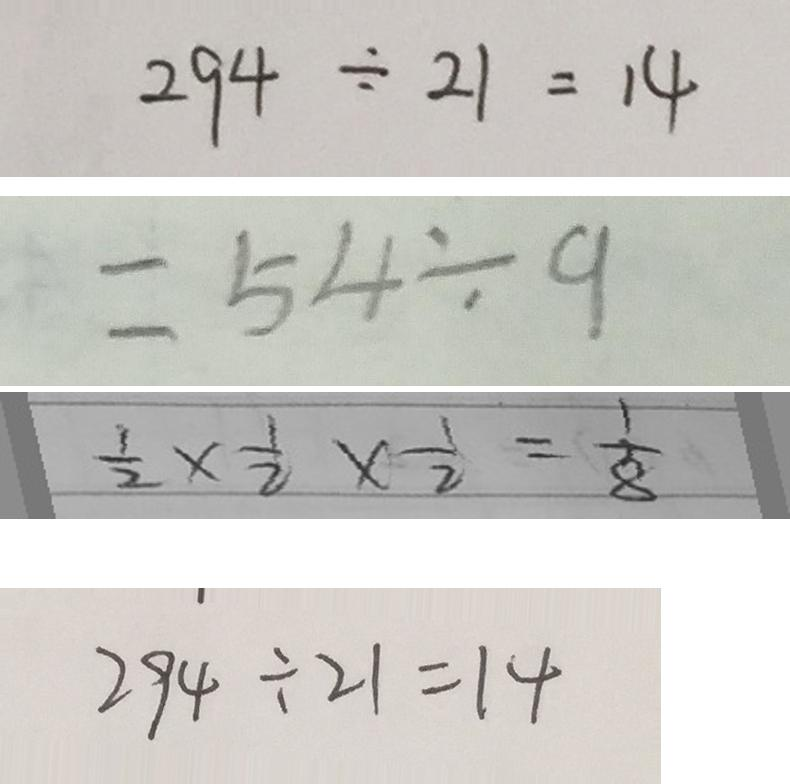<formula> <loc_0><loc_0><loc_500><loc_500>2 9 4 \div 2 1 = 1 4 
 = 5 4 \div 9 
 \frac { 1 } { 2 } \times \frac { 1 } { 2 } \times \frac { 1 } { 2 } = \frac { 1 } { 8 } 
 2 9 4 \div 2 1 = 1 4</formula> 